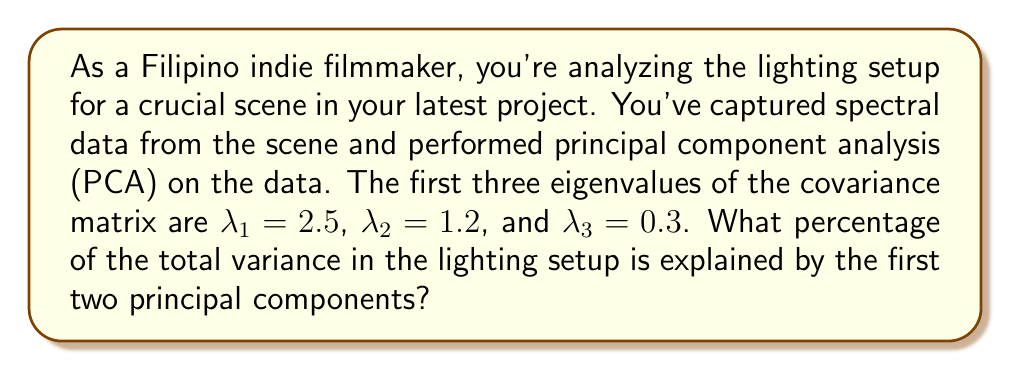Help me with this question. To solve this problem, we'll follow these steps:

1) First, we need to calculate the total variance, which is the sum of all eigenvalues. In this case, we have:

   $$\text{Total Variance} = \lambda_1 + \lambda_2 + \lambda_3 = 2.5 + 1.2 + 0.3 = 4$$

2) Next, we need to calculate the variance explained by the first two principal components:

   $$\text{Variance of PC1 and PC2} = \lambda_1 + \lambda_2 = 2.5 + 1.2 = 3.7$$

3) To find the percentage of variance explained by the first two principal components, we divide the variance of PC1 and PC2 by the total variance and multiply by 100:

   $$\text{Percentage} = \frac{\text{Variance of PC1 and PC2}}{\text{Total Variance}} \times 100\%$$
   
   $$= \frac{3.7}{4} \times 100\% = 0.925 \times 100\% = 92.5\%$$

Therefore, the first two principal components explain 92.5% of the total variance in the lighting setup.
Answer: 92.5% 